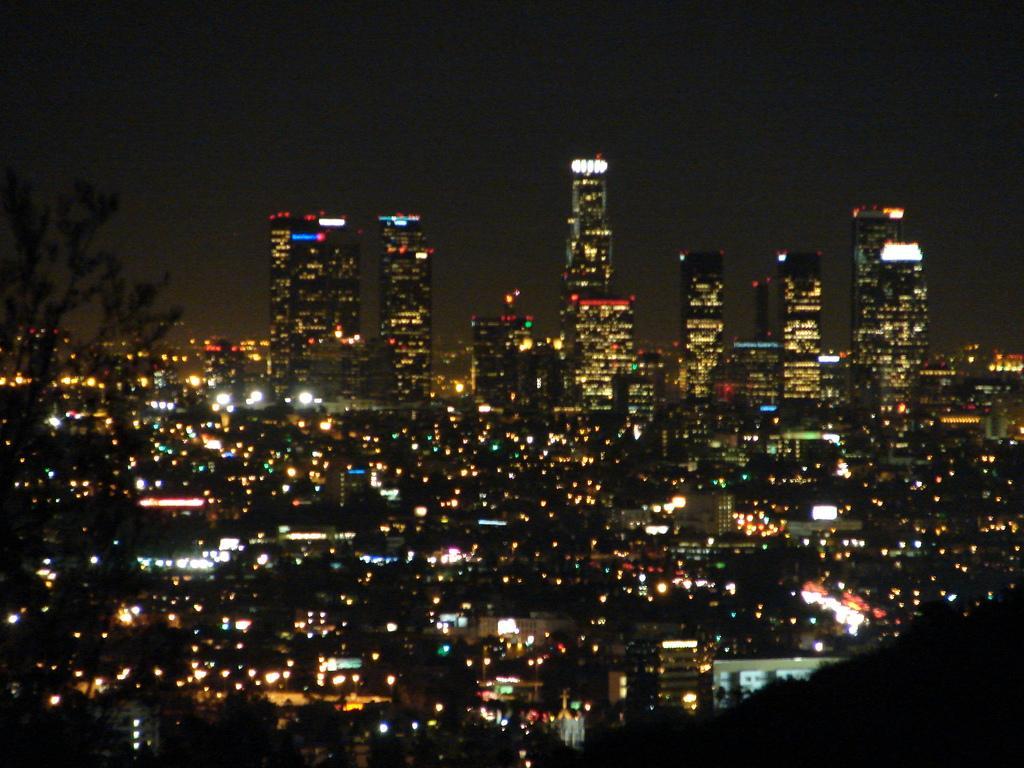Please provide a concise description of this image. This image is taken at the nighttime. In the center of the image there are many buildings. There is a tree to the left side of the image. 